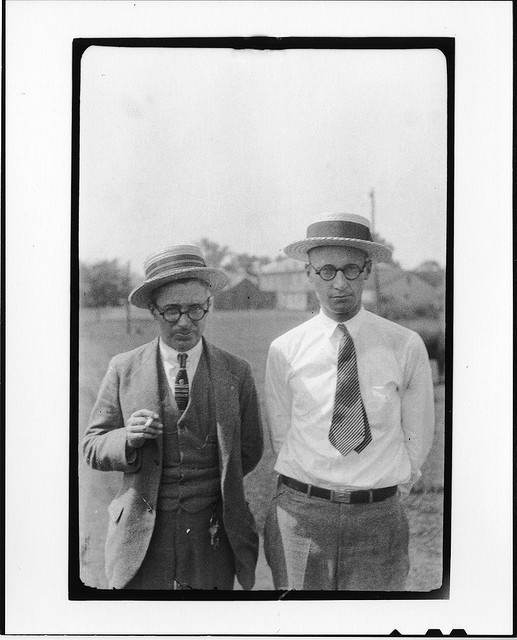Describe the objects in this image and their specific colors. I can see people in white, darkgray, gray, lightgray, and black tones, people in white, black, gray, darkgray, and lightgray tones, tie in white, gray, darkgray, black, and lightgray tones, and tie in gray, black, and white tones in this image. 